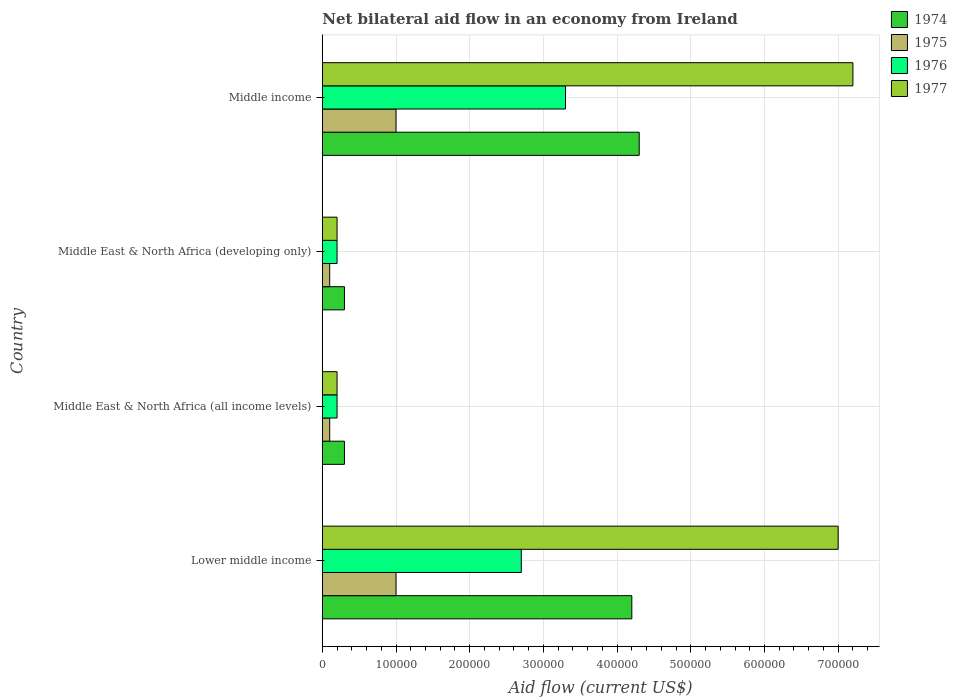How many different coloured bars are there?
Offer a very short reply. 4. Are the number of bars on each tick of the Y-axis equal?
Offer a very short reply. Yes. How many bars are there on the 4th tick from the top?
Ensure brevity in your answer.  4. What is the label of the 1st group of bars from the top?
Keep it short and to the point. Middle income. In which country was the net bilateral aid flow in 1975 maximum?
Ensure brevity in your answer.  Lower middle income. In which country was the net bilateral aid flow in 1976 minimum?
Your answer should be compact. Middle East & North Africa (all income levels). What is the total net bilateral aid flow in 1975 in the graph?
Your response must be concise. 2.20e+05. What is the difference between the net bilateral aid flow in 1974 in Lower middle income and that in Middle income?
Keep it short and to the point. -10000. What is the average net bilateral aid flow in 1974 per country?
Provide a succinct answer. 2.28e+05. What is the difference between the net bilateral aid flow in 1975 and net bilateral aid flow in 1977 in Middle East & North Africa (all income levels)?
Make the answer very short. -10000. In how many countries, is the net bilateral aid flow in 1976 greater than 240000 US$?
Offer a terse response. 2. What is the difference between the highest and the second highest net bilateral aid flow in 1977?
Keep it short and to the point. 2.00e+04. Is the sum of the net bilateral aid flow in 1976 in Middle East & North Africa (all income levels) and Middle East & North Africa (developing only) greater than the maximum net bilateral aid flow in 1974 across all countries?
Ensure brevity in your answer.  No. What does the 4th bar from the top in Middle East & North Africa (all income levels) represents?
Your answer should be compact. 1974. What does the 2nd bar from the bottom in Middle income represents?
Give a very brief answer. 1975. Is it the case that in every country, the sum of the net bilateral aid flow in 1975 and net bilateral aid flow in 1974 is greater than the net bilateral aid flow in 1977?
Keep it short and to the point. No. Are all the bars in the graph horizontal?
Provide a short and direct response. Yes. How many countries are there in the graph?
Provide a succinct answer. 4. What is the difference between two consecutive major ticks on the X-axis?
Make the answer very short. 1.00e+05. Are the values on the major ticks of X-axis written in scientific E-notation?
Offer a very short reply. No. Does the graph contain grids?
Your answer should be compact. Yes. Where does the legend appear in the graph?
Your response must be concise. Top right. How many legend labels are there?
Give a very brief answer. 4. What is the title of the graph?
Provide a succinct answer. Net bilateral aid flow in an economy from Ireland. What is the label or title of the X-axis?
Ensure brevity in your answer.  Aid flow (current US$). What is the Aid flow (current US$) of 1974 in Lower middle income?
Keep it short and to the point. 4.20e+05. What is the Aid flow (current US$) in 1976 in Lower middle income?
Ensure brevity in your answer.  2.70e+05. What is the Aid flow (current US$) in 1974 in Middle East & North Africa (all income levels)?
Offer a very short reply. 3.00e+04. What is the Aid flow (current US$) of 1975 in Middle East & North Africa (all income levels)?
Provide a succinct answer. 10000. What is the Aid flow (current US$) of 1977 in Middle East & North Africa (all income levels)?
Ensure brevity in your answer.  2.00e+04. What is the Aid flow (current US$) in 1975 in Middle East & North Africa (developing only)?
Provide a short and direct response. 10000. What is the Aid flow (current US$) in 1974 in Middle income?
Your answer should be compact. 4.30e+05. What is the Aid flow (current US$) of 1975 in Middle income?
Offer a very short reply. 1.00e+05. What is the Aid flow (current US$) in 1977 in Middle income?
Your response must be concise. 7.20e+05. Across all countries, what is the maximum Aid flow (current US$) of 1975?
Offer a terse response. 1.00e+05. Across all countries, what is the maximum Aid flow (current US$) in 1976?
Your response must be concise. 3.30e+05. Across all countries, what is the maximum Aid flow (current US$) in 1977?
Your answer should be compact. 7.20e+05. Across all countries, what is the minimum Aid flow (current US$) in 1974?
Keep it short and to the point. 3.00e+04. Across all countries, what is the minimum Aid flow (current US$) in 1976?
Provide a succinct answer. 2.00e+04. What is the total Aid flow (current US$) of 1974 in the graph?
Provide a succinct answer. 9.10e+05. What is the total Aid flow (current US$) of 1975 in the graph?
Your answer should be very brief. 2.20e+05. What is the total Aid flow (current US$) in 1976 in the graph?
Provide a succinct answer. 6.40e+05. What is the total Aid flow (current US$) of 1977 in the graph?
Your response must be concise. 1.46e+06. What is the difference between the Aid flow (current US$) in 1976 in Lower middle income and that in Middle East & North Africa (all income levels)?
Ensure brevity in your answer.  2.50e+05. What is the difference between the Aid flow (current US$) of 1977 in Lower middle income and that in Middle East & North Africa (all income levels)?
Ensure brevity in your answer.  6.80e+05. What is the difference between the Aid flow (current US$) in 1975 in Lower middle income and that in Middle East & North Africa (developing only)?
Provide a succinct answer. 9.00e+04. What is the difference between the Aid flow (current US$) of 1976 in Lower middle income and that in Middle East & North Africa (developing only)?
Give a very brief answer. 2.50e+05. What is the difference between the Aid flow (current US$) of 1977 in Lower middle income and that in Middle East & North Africa (developing only)?
Your answer should be compact. 6.80e+05. What is the difference between the Aid flow (current US$) in 1974 in Lower middle income and that in Middle income?
Provide a short and direct response. -10000. What is the difference between the Aid flow (current US$) of 1977 in Lower middle income and that in Middle income?
Your response must be concise. -2.00e+04. What is the difference between the Aid flow (current US$) in 1977 in Middle East & North Africa (all income levels) and that in Middle East & North Africa (developing only)?
Your answer should be compact. 0. What is the difference between the Aid flow (current US$) of 1974 in Middle East & North Africa (all income levels) and that in Middle income?
Make the answer very short. -4.00e+05. What is the difference between the Aid flow (current US$) in 1976 in Middle East & North Africa (all income levels) and that in Middle income?
Give a very brief answer. -3.10e+05. What is the difference between the Aid flow (current US$) in 1977 in Middle East & North Africa (all income levels) and that in Middle income?
Offer a terse response. -7.00e+05. What is the difference between the Aid flow (current US$) in 1974 in Middle East & North Africa (developing only) and that in Middle income?
Your answer should be compact. -4.00e+05. What is the difference between the Aid flow (current US$) in 1975 in Middle East & North Africa (developing only) and that in Middle income?
Make the answer very short. -9.00e+04. What is the difference between the Aid flow (current US$) in 1976 in Middle East & North Africa (developing only) and that in Middle income?
Make the answer very short. -3.10e+05. What is the difference between the Aid flow (current US$) in 1977 in Middle East & North Africa (developing only) and that in Middle income?
Ensure brevity in your answer.  -7.00e+05. What is the difference between the Aid flow (current US$) in 1974 in Lower middle income and the Aid flow (current US$) in 1977 in Middle East & North Africa (all income levels)?
Make the answer very short. 4.00e+05. What is the difference between the Aid flow (current US$) in 1975 in Lower middle income and the Aid flow (current US$) in 1976 in Middle East & North Africa (all income levels)?
Your answer should be compact. 8.00e+04. What is the difference between the Aid flow (current US$) of 1976 in Lower middle income and the Aid flow (current US$) of 1977 in Middle East & North Africa (all income levels)?
Your answer should be compact. 2.50e+05. What is the difference between the Aid flow (current US$) in 1974 in Lower middle income and the Aid flow (current US$) in 1975 in Middle East & North Africa (developing only)?
Offer a very short reply. 4.10e+05. What is the difference between the Aid flow (current US$) of 1974 in Lower middle income and the Aid flow (current US$) of 1976 in Middle East & North Africa (developing only)?
Offer a terse response. 4.00e+05. What is the difference between the Aid flow (current US$) of 1975 in Lower middle income and the Aid flow (current US$) of 1977 in Middle East & North Africa (developing only)?
Offer a very short reply. 8.00e+04. What is the difference between the Aid flow (current US$) of 1974 in Lower middle income and the Aid flow (current US$) of 1975 in Middle income?
Make the answer very short. 3.20e+05. What is the difference between the Aid flow (current US$) in 1975 in Lower middle income and the Aid flow (current US$) in 1977 in Middle income?
Give a very brief answer. -6.20e+05. What is the difference between the Aid flow (current US$) of 1976 in Lower middle income and the Aid flow (current US$) of 1977 in Middle income?
Give a very brief answer. -4.50e+05. What is the difference between the Aid flow (current US$) of 1974 in Middle East & North Africa (all income levels) and the Aid flow (current US$) of 1975 in Middle East & North Africa (developing only)?
Your response must be concise. 2.00e+04. What is the difference between the Aid flow (current US$) in 1974 in Middle East & North Africa (all income levels) and the Aid flow (current US$) in 1977 in Middle East & North Africa (developing only)?
Offer a very short reply. 10000. What is the difference between the Aid flow (current US$) of 1975 in Middle East & North Africa (all income levels) and the Aid flow (current US$) of 1977 in Middle East & North Africa (developing only)?
Offer a terse response. -10000. What is the difference between the Aid flow (current US$) in 1976 in Middle East & North Africa (all income levels) and the Aid flow (current US$) in 1977 in Middle East & North Africa (developing only)?
Give a very brief answer. 0. What is the difference between the Aid flow (current US$) of 1974 in Middle East & North Africa (all income levels) and the Aid flow (current US$) of 1975 in Middle income?
Your response must be concise. -7.00e+04. What is the difference between the Aid flow (current US$) in 1974 in Middle East & North Africa (all income levels) and the Aid flow (current US$) in 1977 in Middle income?
Your answer should be very brief. -6.90e+05. What is the difference between the Aid flow (current US$) in 1975 in Middle East & North Africa (all income levels) and the Aid flow (current US$) in 1976 in Middle income?
Offer a terse response. -3.20e+05. What is the difference between the Aid flow (current US$) in 1975 in Middle East & North Africa (all income levels) and the Aid flow (current US$) in 1977 in Middle income?
Your response must be concise. -7.10e+05. What is the difference between the Aid flow (current US$) in 1976 in Middle East & North Africa (all income levels) and the Aid flow (current US$) in 1977 in Middle income?
Your answer should be compact. -7.00e+05. What is the difference between the Aid flow (current US$) of 1974 in Middle East & North Africa (developing only) and the Aid flow (current US$) of 1975 in Middle income?
Your answer should be very brief. -7.00e+04. What is the difference between the Aid flow (current US$) of 1974 in Middle East & North Africa (developing only) and the Aid flow (current US$) of 1977 in Middle income?
Keep it short and to the point. -6.90e+05. What is the difference between the Aid flow (current US$) of 1975 in Middle East & North Africa (developing only) and the Aid flow (current US$) of 1976 in Middle income?
Offer a very short reply. -3.20e+05. What is the difference between the Aid flow (current US$) in 1975 in Middle East & North Africa (developing only) and the Aid flow (current US$) in 1977 in Middle income?
Keep it short and to the point. -7.10e+05. What is the difference between the Aid flow (current US$) in 1976 in Middle East & North Africa (developing only) and the Aid flow (current US$) in 1977 in Middle income?
Your answer should be compact. -7.00e+05. What is the average Aid flow (current US$) in 1974 per country?
Your answer should be compact. 2.28e+05. What is the average Aid flow (current US$) of 1975 per country?
Your answer should be very brief. 5.50e+04. What is the average Aid flow (current US$) of 1976 per country?
Your response must be concise. 1.60e+05. What is the average Aid flow (current US$) in 1977 per country?
Give a very brief answer. 3.65e+05. What is the difference between the Aid flow (current US$) of 1974 and Aid flow (current US$) of 1975 in Lower middle income?
Provide a short and direct response. 3.20e+05. What is the difference between the Aid flow (current US$) of 1974 and Aid flow (current US$) of 1976 in Lower middle income?
Provide a succinct answer. 1.50e+05. What is the difference between the Aid flow (current US$) of 1974 and Aid flow (current US$) of 1977 in Lower middle income?
Offer a very short reply. -2.80e+05. What is the difference between the Aid flow (current US$) in 1975 and Aid flow (current US$) in 1977 in Lower middle income?
Your answer should be very brief. -6.00e+05. What is the difference between the Aid flow (current US$) of 1976 and Aid flow (current US$) of 1977 in Lower middle income?
Make the answer very short. -4.30e+05. What is the difference between the Aid flow (current US$) in 1975 and Aid flow (current US$) in 1977 in Middle East & North Africa (all income levels)?
Your answer should be very brief. -10000. What is the difference between the Aid flow (current US$) in 1976 and Aid flow (current US$) in 1977 in Middle East & North Africa (all income levels)?
Make the answer very short. 0. What is the difference between the Aid flow (current US$) in 1974 and Aid flow (current US$) in 1975 in Middle East & North Africa (developing only)?
Your response must be concise. 2.00e+04. What is the difference between the Aid flow (current US$) in 1975 and Aid flow (current US$) in 1976 in Middle East & North Africa (developing only)?
Provide a short and direct response. -10000. What is the difference between the Aid flow (current US$) of 1975 and Aid flow (current US$) of 1977 in Middle East & North Africa (developing only)?
Offer a terse response. -10000. What is the difference between the Aid flow (current US$) in 1976 and Aid flow (current US$) in 1977 in Middle East & North Africa (developing only)?
Provide a short and direct response. 0. What is the difference between the Aid flow (current US$) in 1974 and Aid flow (current US$) in 1976 in Middle income?
Your answer should be compact. 1.00e+05. What is the difference between the Aid flow (current US$) of 1975 and Aid flow (current US$) of 1976 in Middle income?
Provide a short and direct response. -2.30e+05. What is the difference between the Aid flow (current US$) of 1975 and Aid flow (current US$) of 1977 in Middle income?
Offer a terse response. -6.20e+05. What is the difference between the Aid flow (current US$) of 1976 and Aid flow (current US$) of 1977 in Middle income?
Provide a short and direct response. -3.90e+05. What is the ratio of the Aid flow (current US$) of 1975 in Lower middle income to that in Middle East & North Africa (all income levels)?
Offer a terse response. 10. What is the ratio of the Aid flow (current US$) in 1977 in Lower middle income to that in Middle East & North Africa (all income levels)?
Give a very brief answer. 35. What is the ratio of the Aid flow (current US$) in 1975 in Lower middle income to that in Middle East & North Africa (developing only)?
Offer a very short reply. 10. What is the ratio of the Aid flow (current US$) in 1976 in Lower middle income to that in Middle East & North Africa (developing only)?
Your answer should be very brief. 13.5. What is the ratio of the Aid flow (current US$) of 1974 in Lower middle income to that in Middle income?
Ensure brevity in your answer.  0.98. What is the ratio of the Aid flow (current US$) in 1975 in Lower middle income to that in Middle income?
Provide a short and direct response. 1. What is the ratio of the Aid flow (current US$) in 1976 in Lower middle income to that in Middle income?
Your answer should be very brief. 0.82. What is the ratio of the Aid flow (current US$) in 1977 in Lower middle income to that in Middle income?
Make the answer very short. 0.97. What is the ratio of the Aid flow (current US$) of 1974 in Middle East & North Africa (all income levels) to that in Middle East & North Africa (developing only)?
Offer a very short reply. 1. What is the ratio of the Aid flow (current US$) of 1975 in Middle East & North Africa (all income levels) to that in Middle East & North Africa (developing only)?
Provide a succinct answer. 1. What is the ratio of the Aid flow (current US$) in 1974 in Middle East & North Africa (all income levels) to that in Middle income?
Offer a very short reply. 0.07. What is the ratio of the Aid flow (current US$) in 1975 in Middle East & North Africa (all income levels) to that in Middle income?
Ensure brevity in your answer.  0.1. What is the ratio of the Aid flow (current US$) of 1976 in Middle East & North Africa (all income levels) to that in Middle income?
Offer a terse response. 0.06. What is the ratio of the Aid flow (current US$) in 1977 in Middle East & North Africa (all income levels) to that in Middle income?
Provide a succinct answer. 0.03. What is the ratio of the Aid flow (current US$) of 1974 in Middle East & North Africa (developing only) to that in Middle income?
Make the answer very short. 0.07. What is the ratio of the Aid flow (current US$) in 1976 in Middle East & North Africa (developing only) to that in Middle income?
Give a very brief answer. 0.06. What is the ratio of the Aid flow (current US$) of 1977 in Middle East & North Africa (developing only) to that in Middle income?
Your answer should be compact. 0.03. What is the difference between the highest and the second highest Aid flow (current US$) in 1974?
Give a very brief answer. 10000. What is the difference between the highest and the lowest Aid flow (current US$) of 1975?
Your answer should be compact. 9.00e+04. 